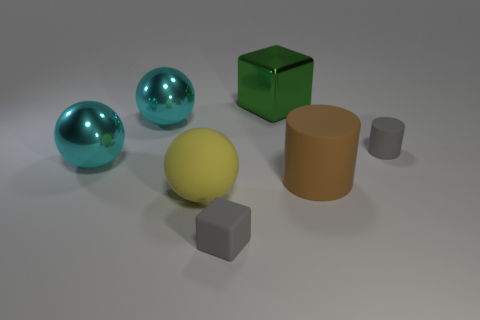The yellow rubber sphere is what size?
Provide a succinct answer. Large. Are there more brown cylinders in front of the yellow thing than large yellow things?
Give a very brief answer. No. Is the number of green metallic things to the right of the big matte cylinder the same as the number of tiny gray cubes that are right of the big yellow sphere?
Provide a succinct answer. No. What color is the large thing that is both to the right of the small gray rubber block and behind the brown object?
Your answer should be very brief. Green. Is there any other thing that has the same size as the yellow ball?
Give a very brief answer. Yes. Are there more large green blocks that are in front of the large green metal thing than green things that are in front of the tiny gray cylinder?
Give a very brief answer. No. Do the yellow thing that is on the left side of the brown object and the rubber block have the same size?
Ensure brevity in your answer.  No. How many large green things are in front of the cyan thing that is in front of the gray thing on the right side of the rubber block?
Offer a terse response. 0. How big is the matte thing that is both on the left side of the gray matte cylinder and right of the large green metallic thing?
Make the answer very short. Large. What number of other things are the same shape as the big green thing?
Offer a terse response. 1. 